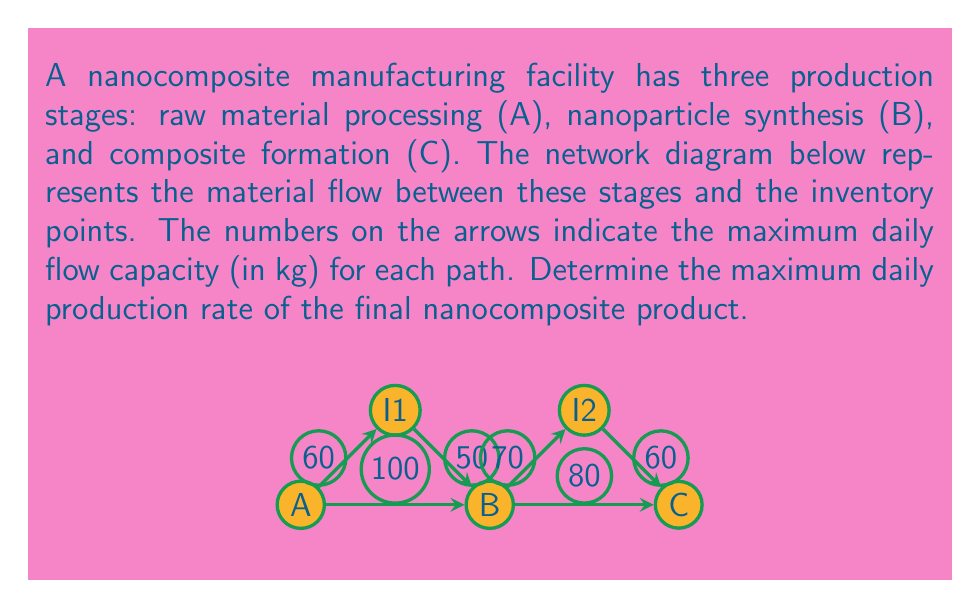Can you answer this question? To solve this problem, we need to use the max-flow min-cut theorem from network flow theory. The steps are as follows:

1) Identify all possible paths from A to C:
   Path 1: A → B → C
   Path 2: A → I1 → B → C
   Path 3: A → B → I2 → C
   Path 4: A → I1 → B → I2 → C

2) Determine the bottleneck (minimum capacity) for each path:
   Path 1: min(100, 80) = 80
   Path 2: min(60, 50, 80) = 50
   Path 3: min(100, 70, 60) = 60
   Path 4: min(60, 50, 70, 60) = 50

3) Find all possible cuts in the network:
   Cut 1: (A) | (B, C, I1, I2)
   Cut 2: (A, I1) | (B, C, I2)
   Cut 3: (A, B, I1) | (C, I2)
   Cut 4: (A, B, I1, I2) | (C)

4) Calculate the capacity of each cut:
   Cut 1: 100 + 60 = 160
   Cut 2: 100 + 50 = 150
   Cut 3: 80 + 70 = 150
   Cut 4: 80 + 60 = 140

5) The maximum flow is equal to the minimum cut capacity:
   $$\text{Max Flow} = \min(160, 150, 150, 140) = 140$$

Therefore, the maximum daily production rate of the final nanocomposite product is 140 kg/day.
Answer: 140 kg/day 